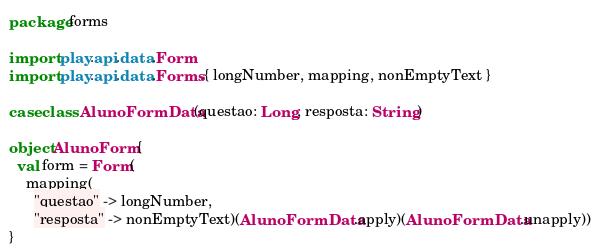Convert code to text. <code><loc_0><loc_0><loc_500><loc_500><_Scala_>package forms

import play.api.data.Form
import play.api.data.Forms.{ longNumber, mapping, nonEmptyText }

case class AlunoFormData(questao: Long, resposta: String)

object AlunoForm {
  val form = Form(
    mapping(
      "questao" -> longNumber,
      "resposta" -> nonEmptyText)(AlunoFormData.apply)(AlunoFormData.unapply))
}
</code> 